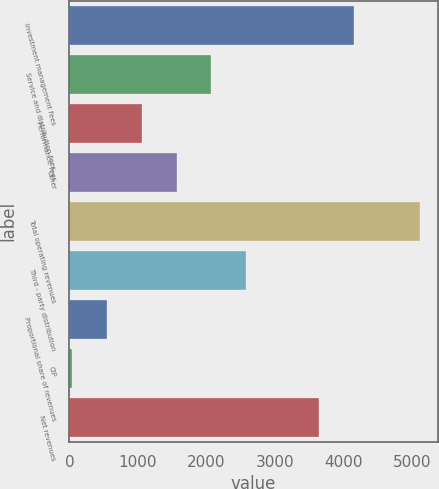<chart> <loc_0><loc_0><loc_500><loc_500><bar_chart><fcel>Investment management fees<fcel>Service and distribution fees<fcel>Performance fees<fcel>Other<fcel>Total operating revenues<fcel>Third - party distribution<fcel>Proportional share of revenues<fcel>CIP<fcel>Net revenues<nl><fcel>4151.57<fcel>2072.68<fcel>1055.94<fcel>1564.31<fcel>5122.9<fcel>2581.05<fcel>547.57<fcel>39.2<fcel>3643.2<nl></chart> 